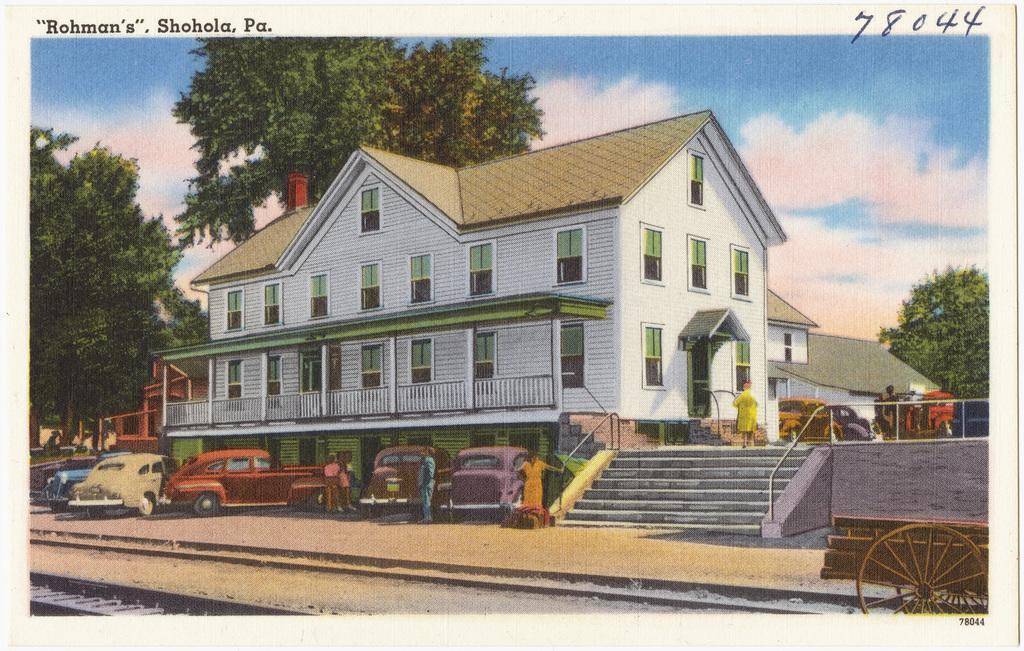Describe this image in one or two sentences. In this image there is a painting of cars, buildings, trees, stairs, persons and the sky is cloudy and on the top of the image there are some texts and numbers written on it. 